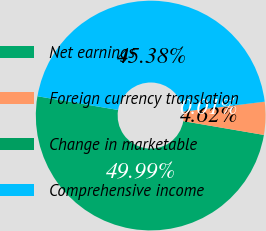<chart> <loc_0><loc_0><loc_500><loc_500><pie_chart><fcel>Net earnings<fcel>Foreign currency translation<fcel>Change in marketable<fcel>Comprehensive income<nl><fcel>49.99%<fcel>4.62%<fcel>0.01%<fcel>45.38%<nl></chart> 